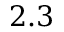Convert formula to latex. <formula><loc_0><loc_0><loc_500><loc_500>2 . 3</formula> 